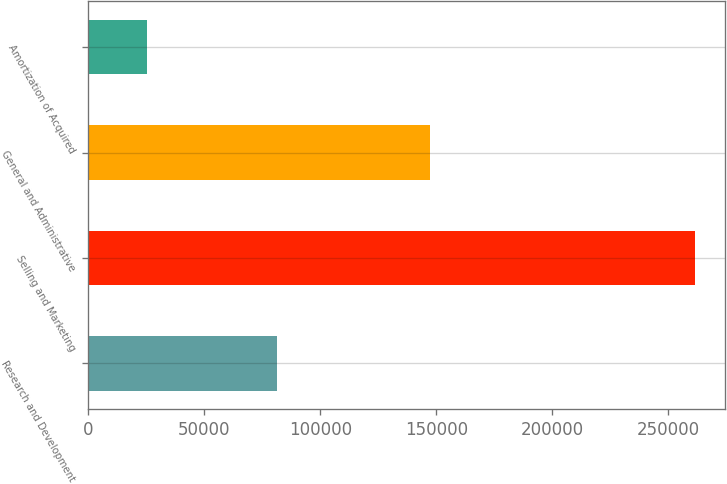Convert chart to OTSL. <chart><loc_0><loc_0><loc_500><loc_500><bar_chart><fcel>Research and Development<fcel>Selling and Marketing<fcel>General and Administrative<fcel>Amortization of Acquired<nl><fcel>81421<fcel>261524<fcel>147405<fcel>25227<nl></chart> 